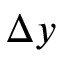Convert formula to latex. <formula><loc_0><loc_0><loc_500><loc_500>\Delta y</formula> 